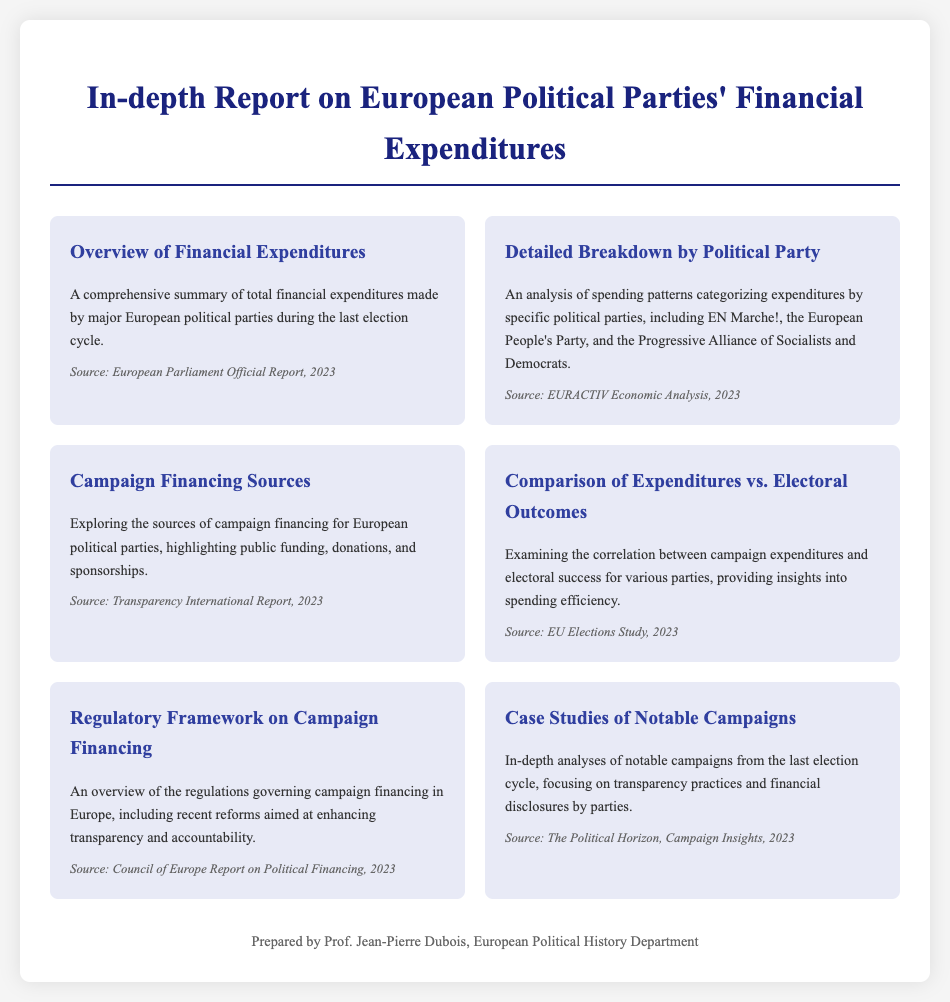What is the title of the report? The title is found in the header section of the document, emphasizing its focus on financial expenditures.
Answer: In-depth Report on European Political Parties' Financial Expenditures Who prepared the document? The footer indicates the person who prepared the document, providing accountability.
Answer: Prof. Jean-Pierre Dubois What is the source of the overview section? Each menu item lists its source, providing transparency on the data used.
Answer: European Parliament Official Report, 2023 What does the section on campaign financing sources explore? The description of the section provides a clear focus on financing details.
Answer: Sources of campaign financing for European political parties How many major political parties are highlighted in the detailed breakdown? The document mentions specific parties, indicating the number of parties examined.
Answer: Three What is one goal of the regulatory framework section? The section aims to address aspects of campaign financing and its regulation, showing its relevance to transparency.
Answer: Enhancing transparency and accountability Which report analyzes the correlation between expenditures and electoral success? The document specifies which sources address different aspects, including electoral outcomes.
Answer: EU Elections Study, 2023 Which political party is mentioned first in the detailed breakdown? The order of mention signifies the specific attention given to each party.
Answer: EN Marche! 